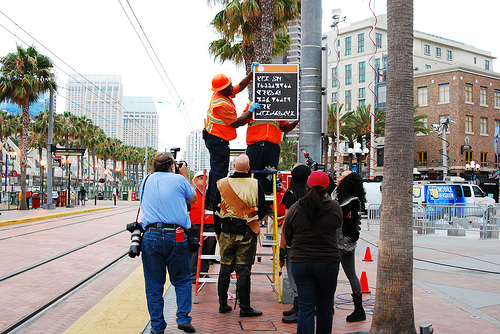<image>
Can you confirm if the man is next to the sign? No. The man is not positioned next to the sign. They are located in different areas of the scene. Is the tree in front of the person? No. The tree is not in front of the person. The spatial positioning shows a different relationship between these objects. 